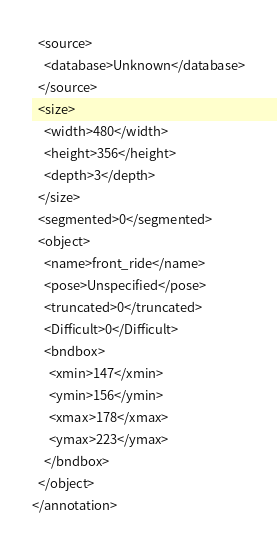Convert code to text. <code><loc_0><loc_0><loc_500><loc_500><_XML_>  <source>
    <database>Unknown</database>
  </source>
  <size>
    <width>480</width>
    <height>356</height>
    <depth>3</depth>
  </size>
  <segmented>0</segmented>
  <object>
    <name>front_ride</name>
    <pose>Unspecified</pose>
    <truncated>0</truncated>
    <Difficult>0</Difficult>
    <bndbox>
      <xmin>147</xmin>
      <ymin>156</ymin>
      <xmax>178</xmax>
      <ymax>223</ymax>
    </bndbox>
  </object>
</annotation>
</code> 